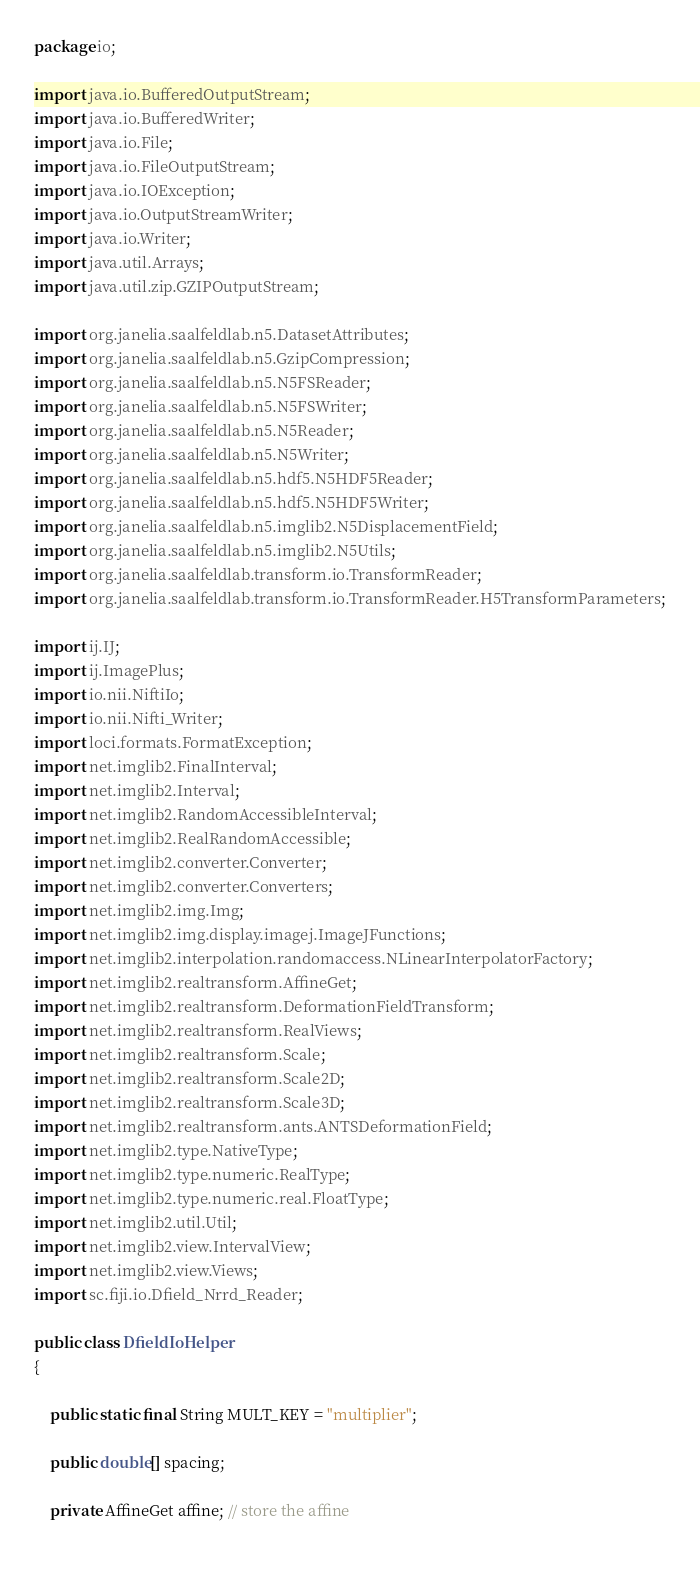<code> <loc_0><loc_0><loc_500><loc_500><_Java_>package io;

import java.io.BufferedOutputStream;
import java.io.BufferedWriter;
import java.io.File;
import java.io.FileOutputStream;
import java.io.IOException;
import java.io.OutputStreamWriter;
import java.io.Writer;
import java.util.Arrays;
import java.util.zip.GZIPOutputStream;

import org.janelia.saalfeldlab.n5.DatasetAttributes;
import org.janelia.saalfeldlab.n5.GzipCompression;
import org.janelia.saalfeldlab.n5.N5FSReader;
import org.janelia.saalfeldlab.n5.N5FSWriter;
import org.janelia.saalfeldlab.n5.N5Reader;
import org.janelia.saalfeldlab.n5.N5Writer;
import org.janelia.saalfeldlab.n5.hdf5.N5HDF5Reader;
import org.janelia.saalfeldlab.n5.hdf5.N5HDF5Writer;
import org.janelia.saalfeldlab.n5.imglib2.N5DisplacementField;
import org.janelia.saalfeldlab.n5.imglib2.N5Utils;
import org.janelia.saalfeldlab.transform.io.TransformReader;
import org.janelia.saalfeldlab.transform.io.TransformReader.H5TransformParameters;

import ij.IJ;
import ij.ImagePlus;
import io.nii.NiftiIo;
import io.nii.Nifti_Writer;
import loci.formats.FormatException;
import net.imglib2.FinalInterval;
import net.imglib2.Interval;
import net.imglib2.RandomAccessibleInterval;
import net.imglib2.RealRandomAccessible;
import net.imglib2.converter.Converter;
import net.imglib2.converter.Converters;
import net.imglib2.img.Img;
import net.imglib2.img.display.imagej.ImageJFunctions;
import net.imglib2.interpolation.randomaccess.NLinearInterpolatorFactory;
import net.imglib2.realtransform.AffineGet;
import net.imglib2.realtransform.DeformationFieldTransform;
import net.imglib2.realtransform.RealViews;
import net.imglib2.realtransform.Scale;
import net.imglib2.realtransform.Scale2D;
import net.imglib2.realtransform.Scale3D;
import net.imglib2.realtransform.ants.ANTSDeformationField;
import net.imglib2.type.NativeType;
import net.imglib2.type.numeric.RealType;
import net.imglib2.type.numeric.real.FloatType;
import net.imglib2.util.Util;
import net.imglib2.view.IntervalView;
import net.imglib2.view.Views;
import sc.fiji.io.Dfield_Nrrd_Reader;

public class DfieldIoHelper
{

	public static final String MULT_KEY = "multiplier";

	public double[] spacing;

	private AffineGet affine; // store the affine
	</code> 